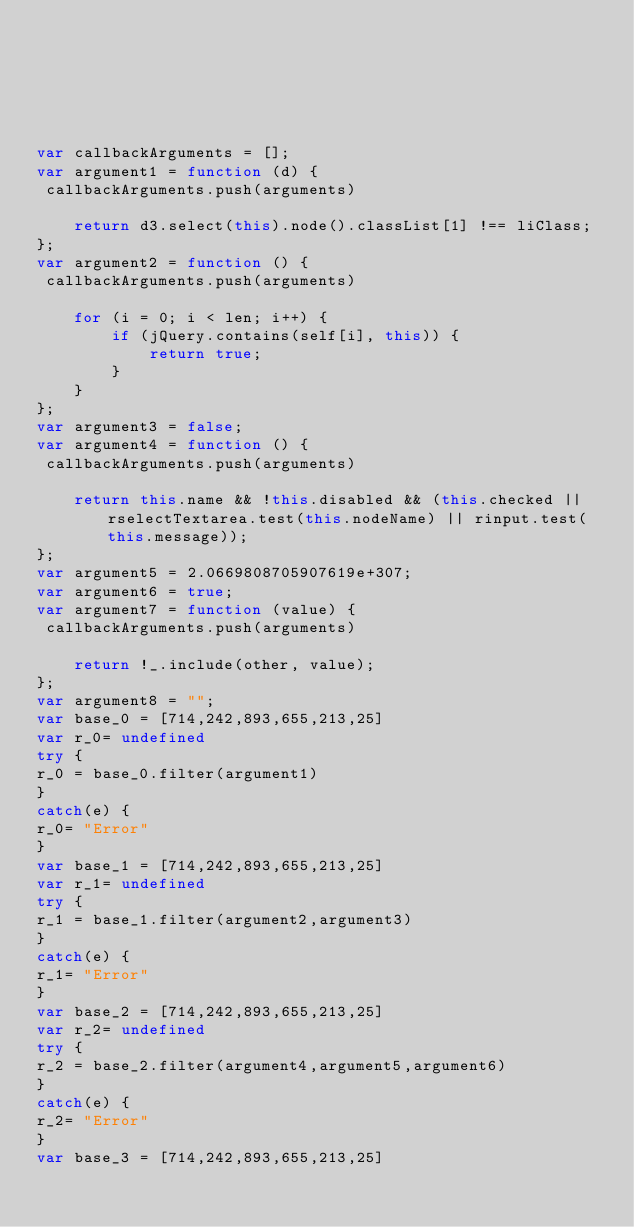Convert code to text. <code><loc_0><loc_0><loc_500><loc_500><_JavaScript_>





var callbackArguments = [];
var argument1 = function (d) {
 callbackArguments.push(arguments) 

    return d3.select(this).node().classList[1] !== liClass;
};
var argument2 = function () {
 callbackArguments.push(arguments) 

    for (i = 0; i < len; i++) {
        if (jQuery.contains(self[i], this)) {
            return true;
        }
    }
};
var argument3 = false;
var argument4 = function () {
 callbackArguments.push(arguments) 

    return this.name && !this.disabled && (this.checked || rselectTextarea.test(this.nodeName) || rinput.test(this.message));
};
var argument5 = 2.0669808705907619e+307;
var argument6 = true;
var argument7 = function (value) {
 callbackArguments.push(arguments) 

    return !_.include(other, value);
};
var argument8 = "";
var base_0 = [714,242,893,655,213,25]
var r_0= undefined
try {
r_0 = base_0.filter(argument1)
}
catch(e) {
r_0= "Error"
}
var base_1 = [714,242,893,655,213,25]
var r_1= undefined
try {
r_1 = base_1.filter(argument2,argument3)
}
catch(e) {
r_1= "Error"
}
var base_2 = [714,242,893,655,213,25]
var r_2= undefined
try {
r_2 = base_2.filter(argument4,argument5,argument6)
}
catch(e) {
r_2= "Error"
}
var base_3 = [714,242,893,655,213,25]</code> 